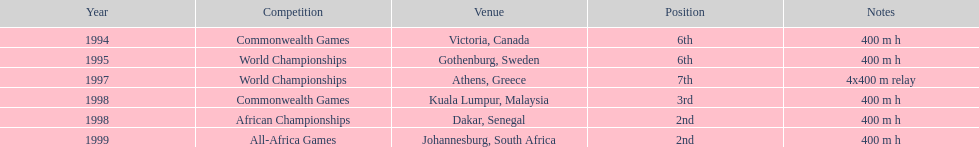What was the designation of the latest competition? All-Africa Games. 